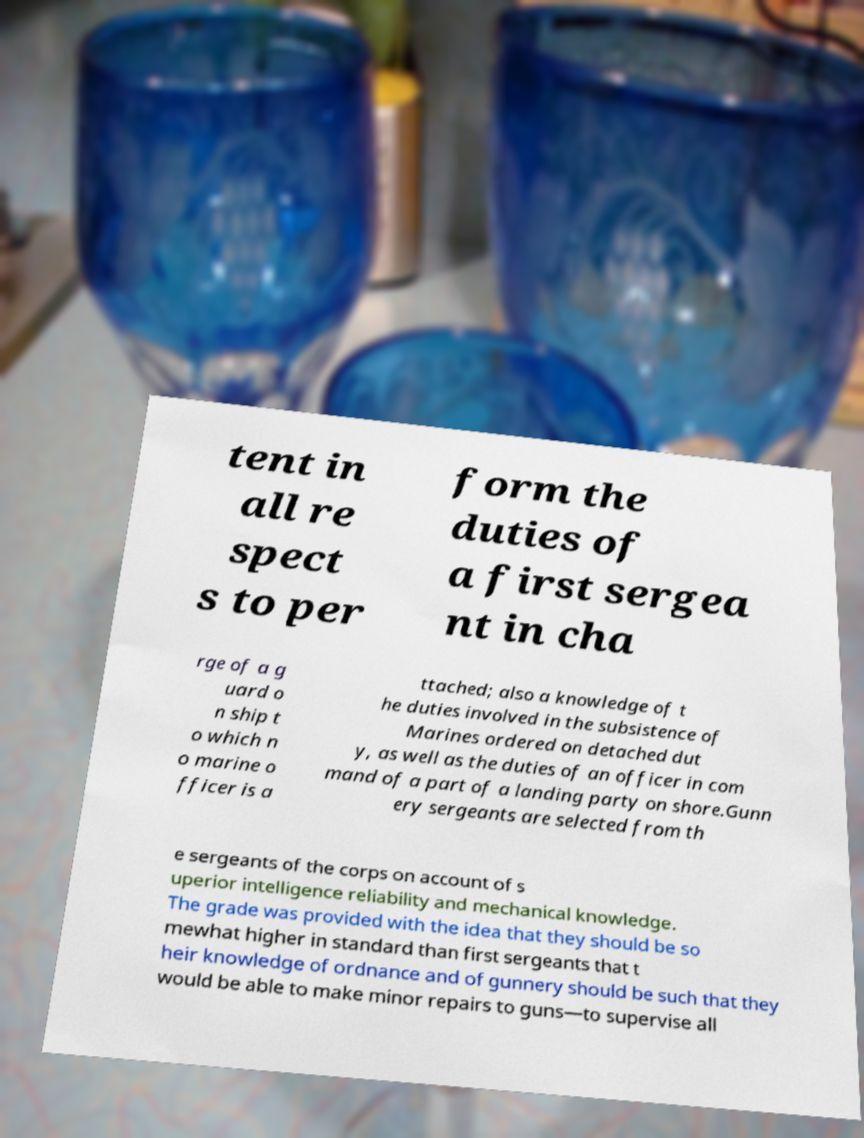What messages or text are displayed in this image? I need them in a readable, typed format. tent in all re spect s to per form the duties of a first sergea nt in cha rge of a g uard o n ship t o which n o marine o fficer is a ttached; also a knowledge of t he duties involved in the subsistence of Marines ordered on detached dut y, as well as the duties of an officer in com mand of a part of a landing party on shore.Gunn ery sergeants are selected from th e sergeants of the corps on account of s uperior intelligence reliability and mechanical knowledge. The grade was provided with the idea that they should be so mewhat higher in standard than first sergeants that t heir knowledge of ordnance and of gunnery should be such that they would be able to make minor repairs to guns—to supervise all 